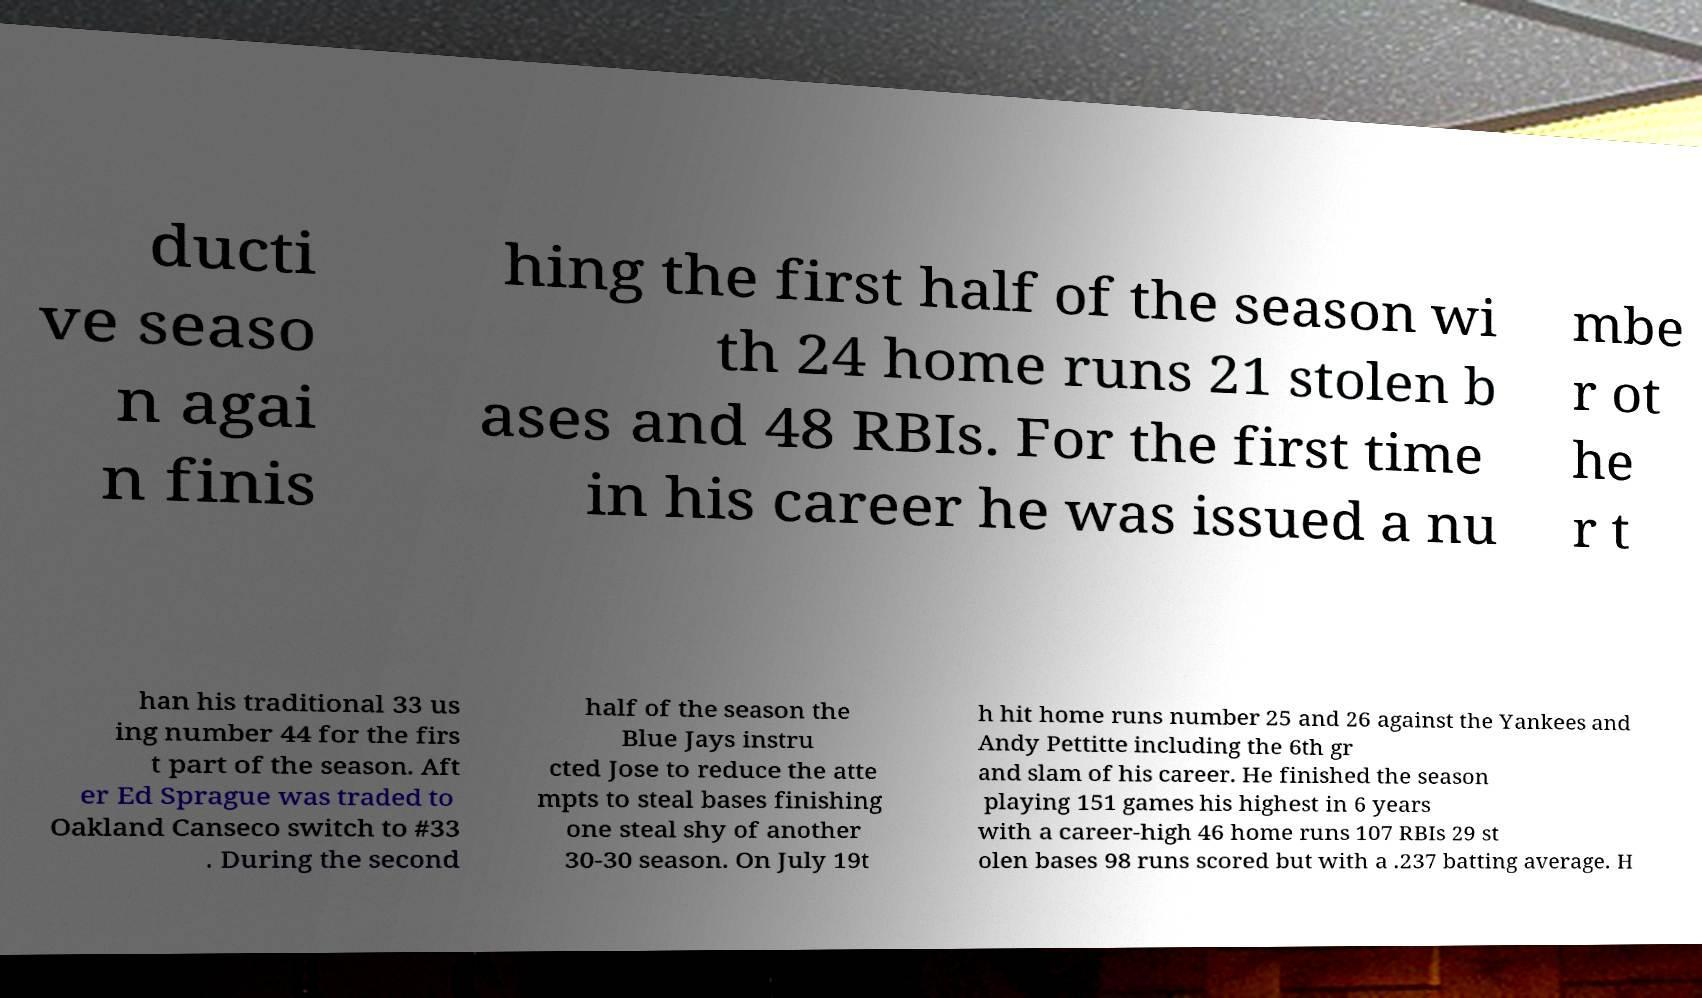Can you accurately transcribe the text from the provided image for me? ducti ve seaso n agai n finis hing the first half of the season wi th 24 home runs 21 stolen b ases and 48 RBIs. For the first time in his career he was issued a nu mbe r ot he r t han his traditional 33 us ing number 44 for the firs t part of the season. Aft er Ed Sprague was traded to Oakland Canseco switch to #33 . During the second half of the season the Blue Jays instru cted Jose to reduce the atte mpts to steal bases finishing one steal shy of another 30-30 season. On July 19t h hit home runs number 25 and 26 against the Yankees and Andy Pettitte including the 6th gr and slam of his career. He finished the season playing 151 games his highest in 6 years with a career-high 46 home runs 107 RBIs 29 st olen bases 98 runs scored but with a .237 batting average. H 